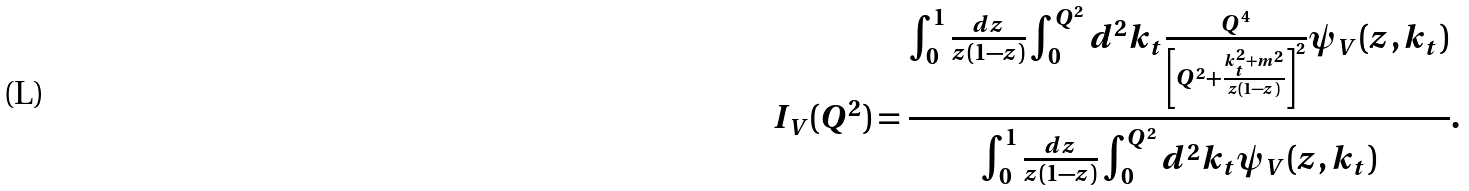<formula> <loc_0><loc_0><loc_500><loc_500>I _ { V } ( Q ^ { 2 } ) = { \frac { \int _ { 0 } ^ { 1 } { \frac { d z } { z ( 1 - z ) } } \int _ { 0 } ^ { Q ^ { 2 } } d ^ { 2 } k _ { t } { \frac { Q ^ { 4 } } { \left [ Q ^ { 2 } + { \frac { k _ { t } ^ { 2 } + m ^ { 2 } } { z ( 1 - z ) } } \right ] ^ { 2 } } } \psi _ { V } ( z , k _ { t } ) } { \int _ { 0 } ^ { 1 } { \frac { d z } { z ( 1 - z ) } } \int _ { 0 } ^ { Q ^ { 2 } } d ^ { 2 } k _ { t } \psi _ { V } ( z , k _ { t } ) } } .</formula> 